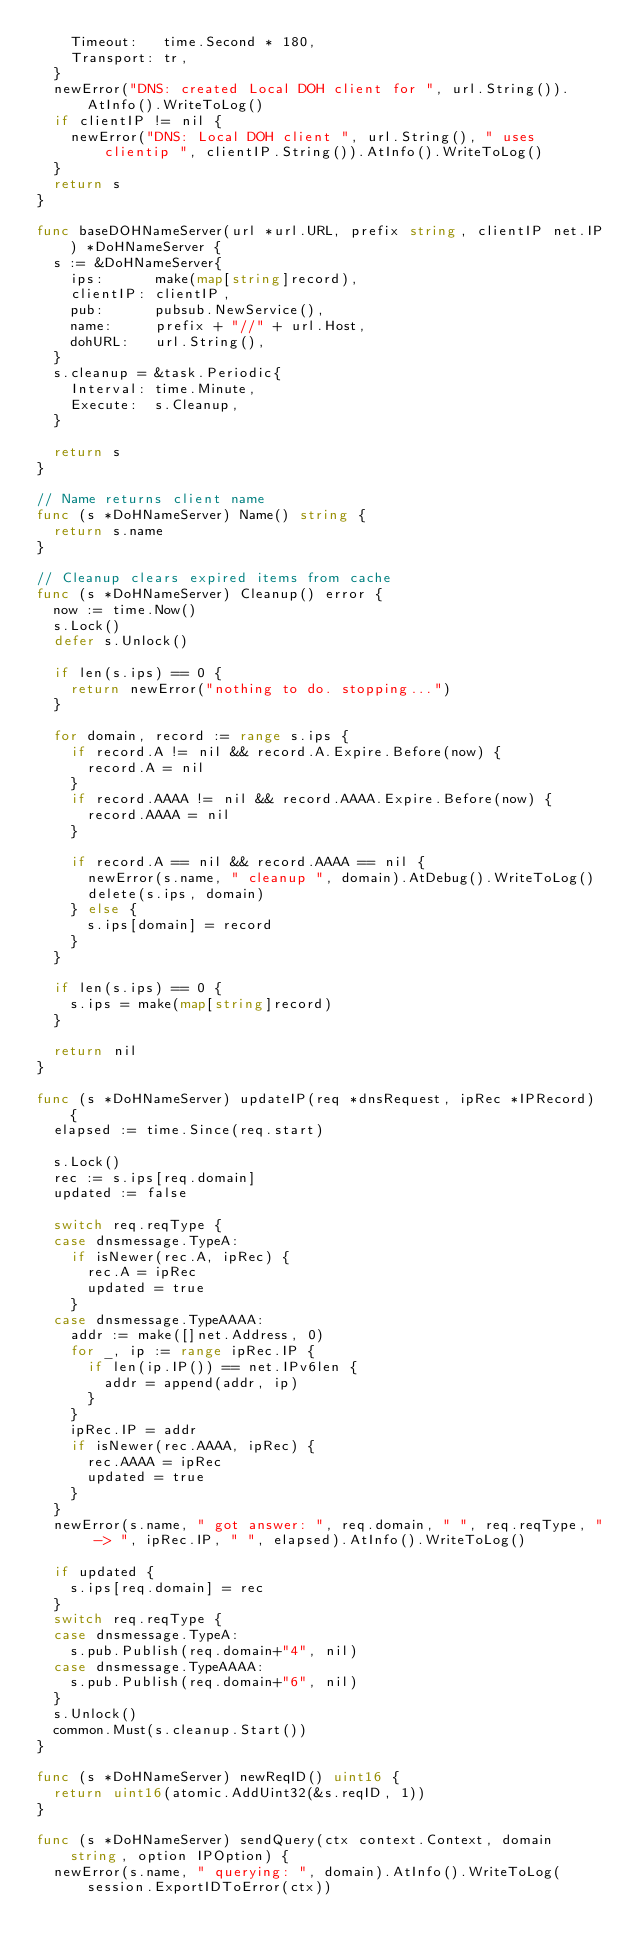Convert code to text. <code><loc_0><loc_0><loc_500><loc_500><_Go_>		Timeout:   time.Second * 180,
		Transport: tr,
	}
	newError("DNS: created Local DOH client for ", url.String()).AtInfo().WriteToLog()
	if clientIP != nil {
		newError("DNS: Local DOH client ", url.String(), " uses clientip ", clientIP.String()).AtInfo().WriteToLog()
	}
	return s
}

func baseDOHNameServer(url *url.URL, prefix string, clientIP net.IP) *DoHNameServer {
	s := &DoHNameServer{
		ips:      make(map[string]record),
		clientIP: clientIP,
		pub:      pubsub.NewService(),
		name:     prefix + "//" + url.Host,
		dohURL:   url.String(),
	}
	s.cleanup = &task.Periodic{
		Interval: time.Minute,
		Execute:  s.Cleanup,
	}

	return s
}

// Name returns client name
func (s *DoHNameServer) Name() string {
	return s.name
}

// Cleanup clears expired items from cache
func (s *DoHNameServer) Cleanup() error {
	now := time.Now()
	s.Lock()
	defer s.Unlock()

	if len(s.ips) == 0 {
		return newError("nothing to do. stopping...")
	}

	for domain, record := range s.ips {
		if record.A != nil && record.A.Expire.Before(now) {
			record.A = nil
		}
		if record.AAAA != nil && record.AAAA.Expire.Before(now) {
			record.AAAA = nil
		}

		if record.A == nil && record.AAAA == nil {
			newError(s.name, " cleanup ", domain).AtDebug().WriteToLog()
			delete(s.ips, domain)
		} else {
			s.ips[domain] = record
		}
	}

	if len(s.ips) == 0 {
		s.ips = make(map[string]record)
	}

	return nil
}

func (s *DoHNameServer) updateIP(req *dnsRequest, ipRec *IPRecord) {
	elapsed := time.Since(req.start)

	s.Lock()
	rec := s.ips[req.domain]
	updated := false

	switch req.reqType {
	case dnsmessage.TypeA:
		if isNewer(rec.A, ipRec) {
			rec.A = ipRec
			updated = true
		}
	case dnsmessage.TypeAAAA:
		addr := make([]net.Address, 0)
		for _, ip := range ipRec.IP {
			if len(ip.IP()) == net.IPv6len {
				addr = append(addr, ip)
			}
		}
		ipRec.IP = addr
		if isNewer(rec.AAAA, ipRec) {
			rec.AAAA = ipRec
			updated = true
		}
	}
	newError(s.name, " got answer: ", req.domain, " ", req.reqType, " -> ", ipRec.IP, " ", elapsed).AtInfo().WriteToLog()

	if updated {
		s.ips[req.domain] = rec
	}
	switch req.reqType {
	case dnsmessage.TypeA:
		s.pub.Publish(req.domain+"4", nil)
	case dnsmessage.TypeAAAA:
		s.pub.Publish(req.domain+"6", nil)
	}
	s.Unlock()
	common.Must(s.cleanup.Start())
}

func (s *DoHNameServer) newReqID() uint16 {
	return uint16(atomic.AddUint32(&s.reqID, 1))
}

func (s *DoHNameServer) sendQuery(ctx context.Context, domain string, option IPOption) {
	newError(s.name, " querying: ", domain).AtInfo().WriteToLog(session.ExportIDToError(ctx))
</code> 